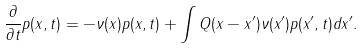<formula> <loc_0><loc_0><loc_500><loc_500>\frac { \partial } { \partial t } p ( x , t ) = - \nu ( x ) p ( x , t ) + \int Q ( x - x ^ { \prime } ) \nu ( x ^ { \prime } ) p ( x ^ { \prime } , t ) d x ^ { \prime } .</formula> 